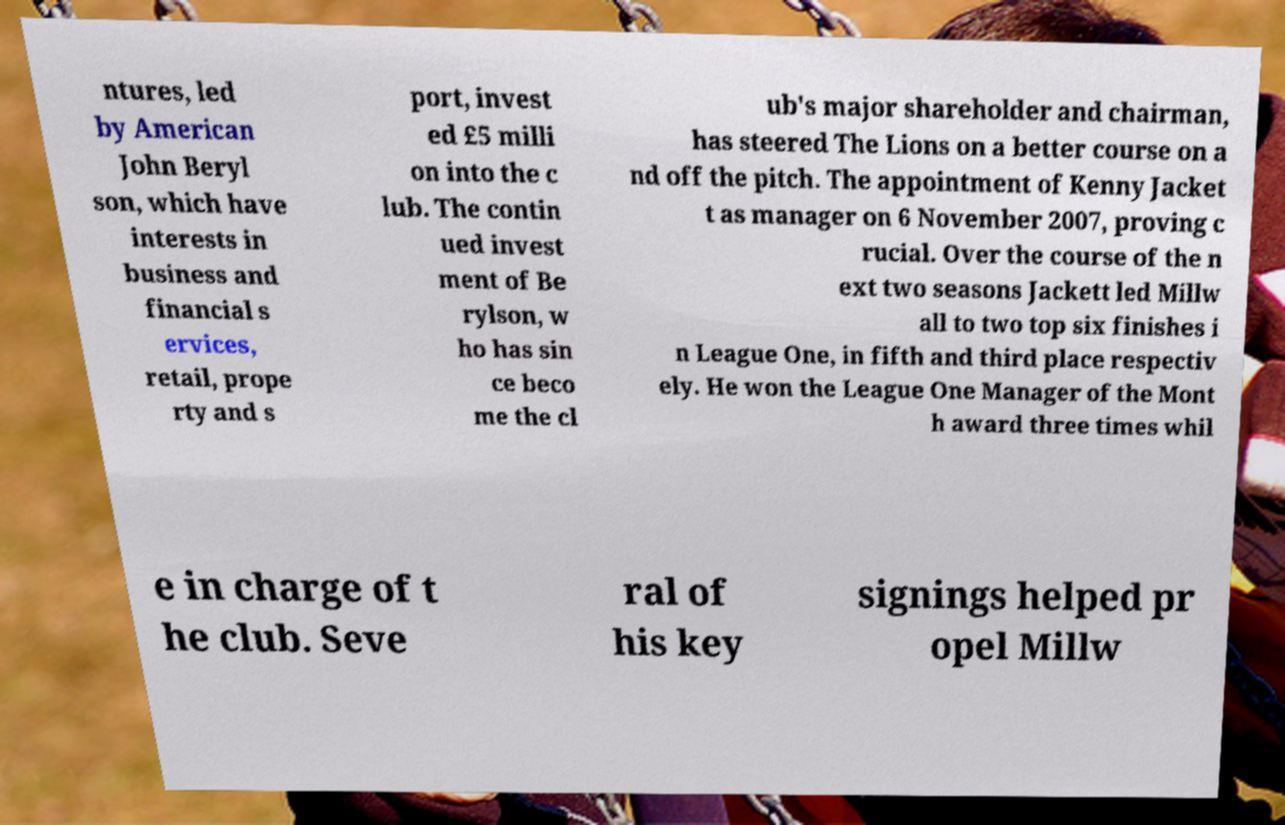Could you extract and type out the text from this image? ntures, led by American John Beryl son, which have interests in business and financial s ervices, retail, prope rty and s port, invest ed £5 milli on into the c lub. The contin ued invest ment of Be rylson, w ho has sin ce beco me the cl ub's major shareholder and chairman, has steered The Lions on a better course on a nd off the pitch. The appointment of Kenny Jacket t as manager on 6 November 2007, proving c rucial. Over the course of the n ext two seasons Jackett led Millw all to two top six finishes i n League One, in fifth and third place respectiv ely. He won the League One Manager of the Mont h award three times whil e in charge of t he club. Seve ral of his key signings helped pr opel Millw 